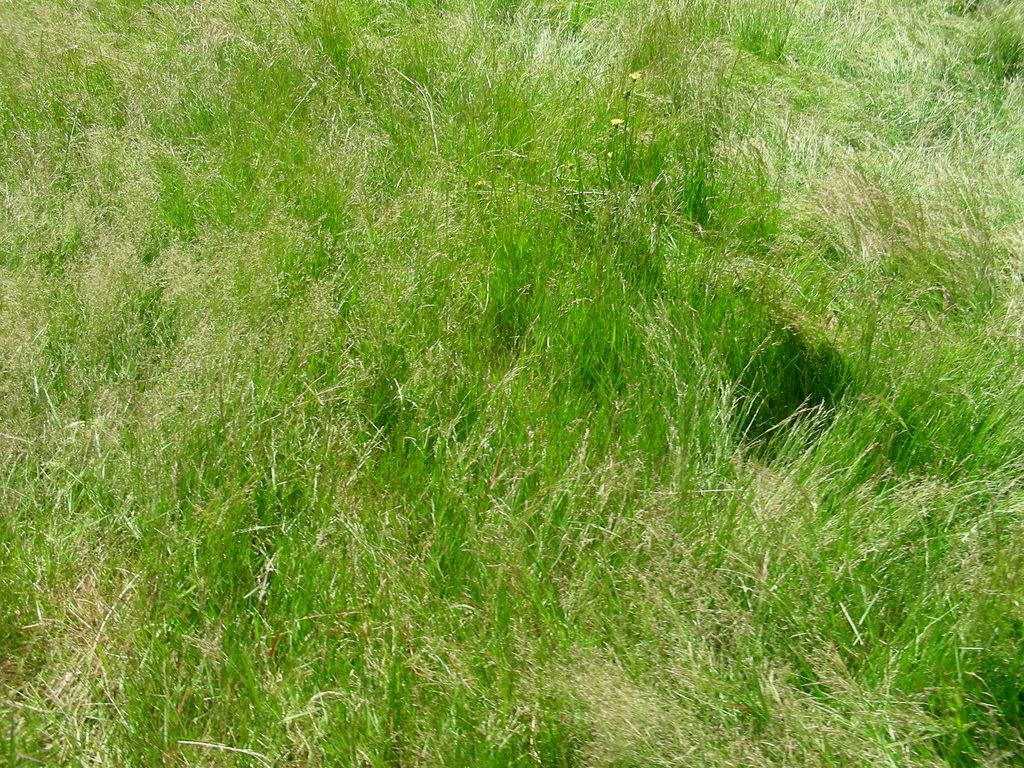What type of vegetation can be seen in the image? There is grass in the image. What level of difficulty is the beginner stage of the grass in the image? The image does not provide information about the difficulty level or stages of the grass. 